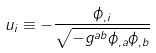<formula> <loc_0><loc_0><loc_500><loc_500>u _ { i } \equiv - \frac { \phi _ { , i } } { \sqrt { - g ^ { a b } \phi _ { , a } \phi _ { , b } } }</formula> 